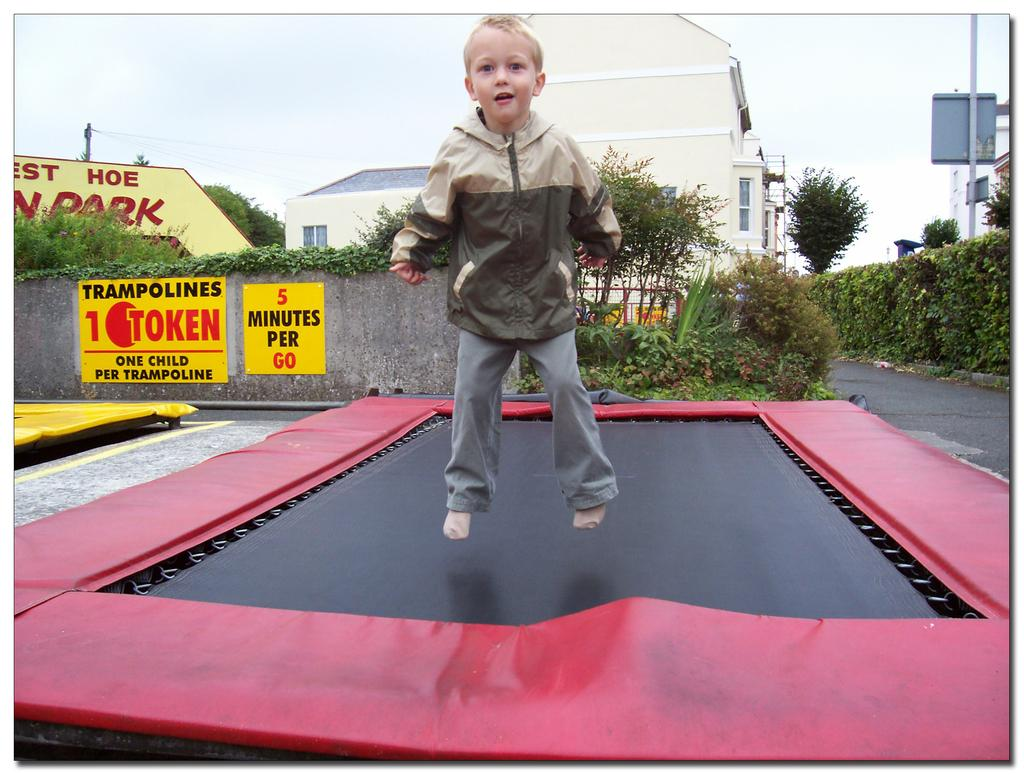Who is the main subject in the image? There is a boy in the image. What is the boy doing in the image? The boy is jumping on a trampoline. What can be seen in the background of the image? There are buildings, trees, and a wall with text in the image. What other objects are present in the image? There are plants, poles, and a trampoline. How would you describe the weather in the image? The sky is cloudy in the image. What type of scarecrow can be seen in the boy's bedroom in the image? There is no scarecrow or bedroom present in the image. How many eyes does the boy have in the image? The image does not show the boy's eyes, so it is impossible to determine the number of eyes he has. 